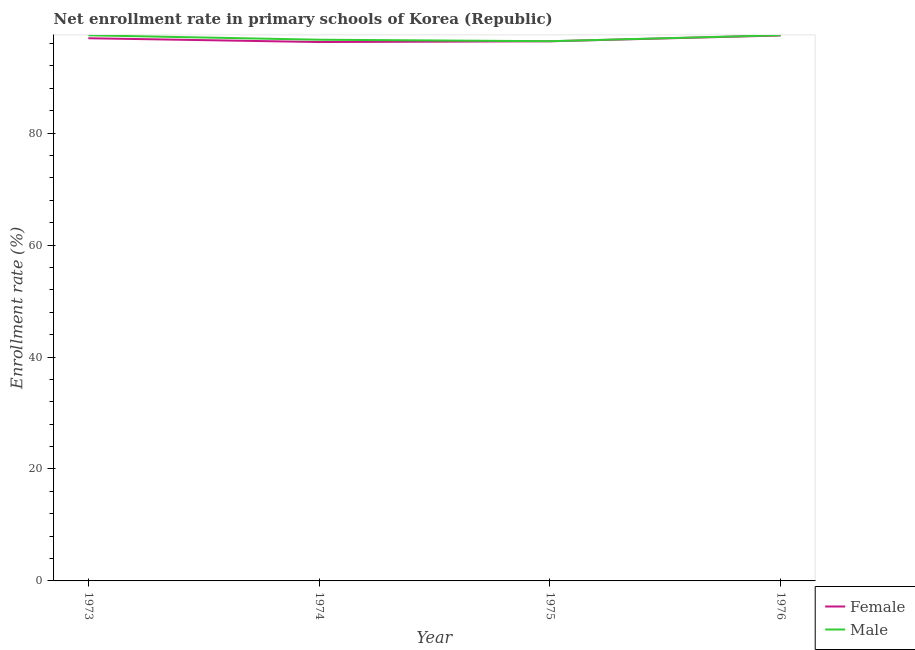Does the line corresponding to enrollment rate of male students intersect with the line corresponding to enrollment rate of female students?
Your answer should be compact. No. Is the number of lines equal to the number of legend labels?
Provide a succinct answer. Yes. What is the enrollment rate of female students in 1974?
Provide a short and direct response. 96.27. Across all years, what is the maximum enrollment rate of female students?
Give a very brief answer. 97.44. Across all years, what is the minimum enrollment rate of female students?
Your response must be concise. 96.27. In which year was the enrollment rate of female students maximum?
Keep it short and to the point. 1976. In which year was the enrollment rate of male students minimum?
Keep it short and to the point. 1975. What is the total enrollment rate of male students in the graph?
Offer a terse response. 388.06. What is the difference between the enrollment rate of male students in 1974 and that in 1976?
Your answer should be very brief. -0.8. What is the difference between the enrollment rate of female students in 1974 and the enrollment rate of male students in 1973?
Your response must be concise. -1.2. What is the average enrollment rate of male students per year?
Provide a succinct answer. 97.02. In the year 1974, what is the difference between the enrollment rate of male students and enrollment rate of female students?
Your answer should be very brief. 0.41. In how many years, is the enrollment rate of female students greater than 60 %?
Offer a very short reply. 4. What is the ratio of the enrollment rate of male students in 1975 to that in 1976?
Offer a terse response. 0.99. Is the enrollment rate of female students in 1973 less than that in 1976?
Your answer should be compact. Yes. Is the difference between the enrollment rate of male students in 1974 and 1976 greater than the difference between the enrollment rate of female students in 1974 and 1976?
Ensure brevity in your answer.  Yes. What is the difference between the highest and the second highest enrollment rate of male students?
Provide a short and direct response. 0.01. What is the difference between the highest and the lowest enrollment rate of female students?
Ensure brevity in your answer.  1.17. In how many years, is the enrollment rate of male students greater than the average enrollment rate of male students taken over all years?
Give a very brief answer. 2. Is the enrollment rate of male students strictly greater than the enrollment rate of female students over the years?
Your answer should be very brief. Yes. Is the enrollment rate of male students strictly less than the enrollment rate of female students over the years?
Your response must be concise. No. Are the values on the major ticks of Y-axis written in scientific E-notation?
Your answer should be very brief. No. Does the graph contain grids?
Offer a terse response. No. Where does the legend appear in the graph?
Provide a short and direct response. Bottom right. What is the title of the graph?
Your answer should be very brief. Net enrollment rate in primary schools of Korea (Republic). What is the label or title of the X-axis?
Keep it short and to the point. Year. What is the label or title of the Y-axis?
Your response must be concise. Enrollment rate (%). What is the Enrollment rate (%) in Female in 1973?
Your response must be concise. 96.95. What is the Enrollment rate (%) in Male in 1973?
Keep it short and to the point. 97.47. What is the Enrollment rate (%) in Female in 1974?
Provide a short and direct response. 96.27. What is the Enrollment rate (%) of Male in 1974?
Your answer should be compact. 96.68. What is the Enrollment rate (%) of Female in 1975?
Your answer should be compact. 96.4. What is the Enrollment rate (%) in Male in 1975?
Provide a short and direct response. 96.42. What is the Enrollment rate (%) in Female in 1976?
Your response must be concise. 97.44. What is the Enrollment rate (%) of Male in 1976?
Keep it short and to the point. 97.49. Across all years, what is the maximum Enrollment rate (%) of Female?
Make the answer very short. 97.44. Across all years, what is the maximum Enrollment rate (%) of Male?
Provide a succinct answer. 97.49. Across all years, what is the minimum Enrollment rate (%) of Female?
Ensure brevity in your answer.  96.27. Across all years, what is the minimum Enrollment rate (%) of Male?
Provide a succinct answer. 96.42. What is the total Enrollment rate (%) of Female in the graph?
Keep it short and to the point. 387.06. What is the total Enrollment rate (%) of Male in the graph?
Offer a very short reply. 388.06. What is the difference between the Enrollment rate (%) of Female in 1973 and that in 1974?
Give a very brief answer. 0.68. What is the difference between the Enrollment rate (%) in Male in 1973 and that in 1974?
Ensure brevity in your answer.  0.79. What is the difference between the Enrollment rate (%) in Female in 1973 and that in 1975?
Make the answer very short. 0.55. What is the difference between the Enrollment rate (%) in Male in 1973 and that in 1975?
Make the answer very short. 1.06. What is the difference between the Enrollment rate (%) in Female in 1973 and that in 1976?
Keep it short and to the point. -0.49. What is the difference between the Enrollment rate (%) in Male in 1973 and that in 1976?
Offer a very short reply. -0.01. What is the difference between the Enrollment rate (%) of Female in 1974 and that in 1975?
Offer a very short reply. -0.13. What is the difference between the Enrollment rate (%) in Male in 1974 and that in 1975?
Offer a terse response. 0.27. What is the difference between the Enrollment rate (%) in Female in 1974 and that in 1976?
Your answer should be compact. -1.17. What is the difference between the Enrollment rate (%) in Male in 1974 and that in 1976?
Your response must be concise. -0.8. What is the difference between the Enrollment rate (%) in Female in 1975 and that in 1976?
Your answer should be compact. -1.04. What is the difference between the Enrollment rate (%) in Male in 1975 and that in 1976?
Keep it short and to the point. -1.07. What is the difference between the Enrollment rate (%) in Female in 1973 and the Enrollment rate (%) in Male in 1974?
Ensure brevity in your answer.  0.26. What is the difference between the Enrollment rate (%) of Female in 1973 and the Enrollment rate (%) of Male in 1975?
Your answer should be very brief. 0.53. What is the difference between the Enrollment rate (%) in Female in 1973 and the Enrollment rate (%) in Male in 1976?
Your answer should be very brief. -0.54. What is the difference between the Enrollment rate (%) in Female in 1974 and the Enrollment rate (%) in Male in 1975?
Keep it short and to the point. -0.15. What is the difference between the Enrollment rate (%) of Female in 1974 and the Enrollment rate (%) of Male in 1976?
Your answer should be very brief. -1.22. What is the difference between the Enrollment rate (%) of Female in 1975 and the Enrollment rate (%) of Male in 1976?
Give a very brief answer. -1.09. What is the average Enrollment rate (%) of Female per year?
Your response must be concise. 96.77. What is the average Enrollment rate (%) of Male per year?
Your answer should be very brief. 97.02. In the year 1973, what is the difference between the Enrollment rate (%) in Female and Enrollment rate (%) in Male?
Your answer should be compact. -0.53. In the year 1974, what is the difference between the Enrollment rate (%) of Female and Enrollment rate (%) of Male?
Provide a short and direct response. -0.41. In the year 1975, what is the difference between the Enrollment rate (%) of Female and Enrollment rate (%) of Male?
Your answer should be compact. -0.02. In the year 1976, what is the difference between the Enrollment rate (%) in Female and Enrollment rate (%) in Male?
Provide a succinct answer. -0.05. What is the ratio of the Enrollment rate (%) in Female in 1973 to that in 1974?
Your answer should be compact. 1.01. What is the ratio of the Enrollment rate (%) of Male in 1973 to that in 1974?
Keep it short and to the point. 1.01. What is the ratio of the Enrollment rate (%) in Female in 1973 to that in 1975?
Provide a short and direct response. 1.01. What is the ratio of the Enrollment rate (%) in Male in 1973 to that in 1975?
Your answer should be very brief. 1.01. What is the ratio of the Enrollment rate (%) of Male in 1973 to that in 1976?
Your answer should be compact. 1. What is the ratio of the Enrollment rate (%) in Male in 1974 to that in 1975?
Make the answer very short. 1. What is the ratio of the Enrollment rate (%) in Female in 1974 to that in 1976?
Offer a very short reply. 0.99. What is the ratio of the Enrollment rate (%) of Male in 1974 to that in 1976?
Your answer should be compact. 0.99. What is the ratio of the Enrollment rate (%) in Female in 1975 to that in 1976?
Provide a short and direct response. 0.99. What is the ratio of the Enrollment rate (%) of Male in 1975 to that in 1976?
Offer a very short reply. 0.99. What is the difference between the highest and the second highest Enrollment rate (%) in Female?
Provide a succinct answer. 0.49. What is the difference between the highest and the second highest Enrollment rate (%) in Male?
Keep it short and to the point. 0.01. What is the difference between the highest and the lowest Enrollment rate (%) in Female?
Give a very brief answer. 1.17. What is the difference between the highest and the lowest Enrollment rate (%) in Male?
Offer a very short reply. 1.07. 